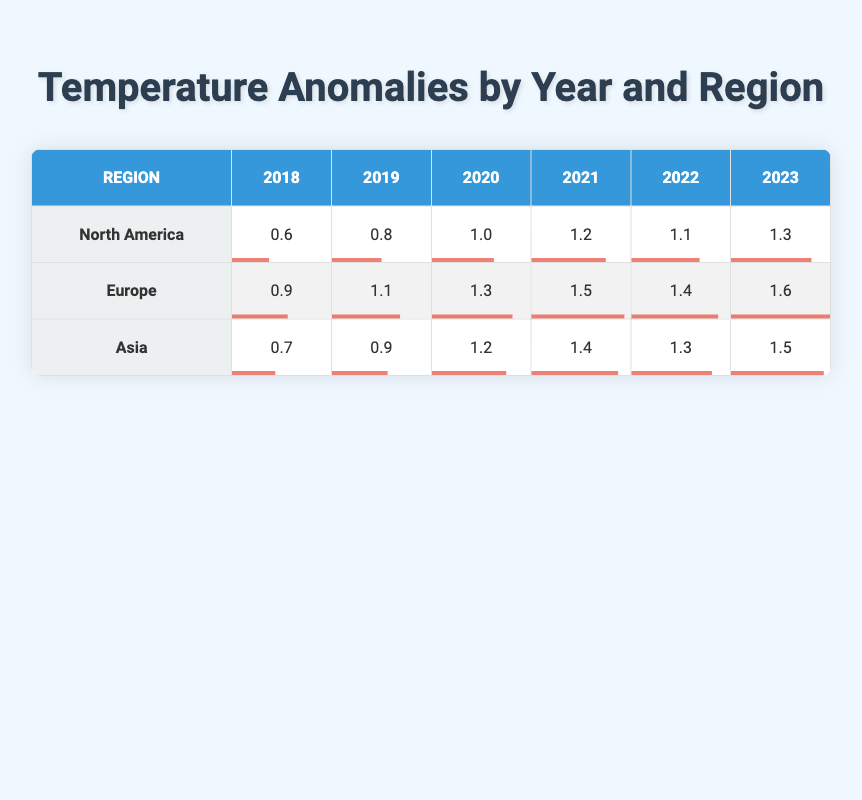What was the temperature anomaly for North America in 2021? Looking at the row for North America in the column for 2021, the temperature anomaly is 1.2 Celsius.
Answer: 1.2 Which region had the highest temperature anomaly in 2023? In the year 2023, we examine the anomalies for each region: North America (1.3), Europe (1.6), and Asia (1.5). Europe has the highest anomaly at 1.6 Celsius.
Answer: 1.6 What is the difference in temperature anomalies between Europe and Asia in 2022? For Europe, the anomaly in 2022 is 1.4 Celsius, while for Asia, it is 1.3 Celsius. The difference is 1.4 - 1.3 = 0.1 Celsius.
Answer: 0.1 Did North America experience a decrease in temperature anomaly from 2020 to 2021? The temperature anomaly for North America in 2020 was 1.0 Celsius, and in 2021 it was 1.2 Celsius. This indicates an increase, not a decrease.
Answer: No What was the average temperature anomaly across all regions for the year 2019? The anomalies for 2019 are North America (0.8), Europe (1.1), and Asia (0.9). The total is 0.8 + 1.1 + 0.9 = 2.8. Dividing by 3 gives an average of 2.8 / 3 = 0.933.
Answer: 0.933 How many years featured a temperature anomaly above 1.0 Celsius for Asia? Reviewing the anomalies for Asia: 1.2 in 2020, 1.4 in 2021, 1.3 in 2022, and 1.5 in 2023. Counting these years gives us a total of 4 years above 1.0 Celsius.
Answer: 4 Which region consistently had the lowest temperature anomalies from 2018 to 2023? By reviewing each year's data for all regions, we see that North America started with 0.6 in 2018 and ended with 1.3 in 2023, while the highest anomaly was in Europe. Hence, Asia had the lowest values (0.7, 0.9, 1.2, 1.4, 1.3, 1.5), confirming it consistently had the lowest.
Answer: Asia 